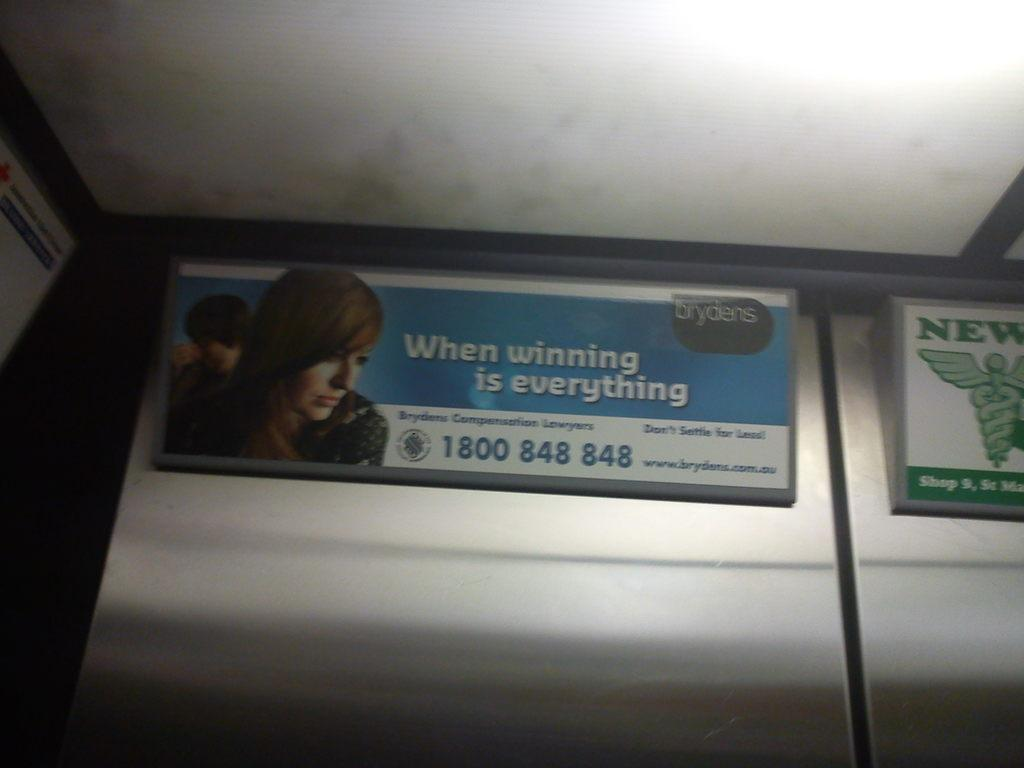What is attached to the wall in the image? There are name boards on the wall in the image. What can be seen on the name boards? People and symbols are present on the name boards. What type of information is visible on the name boards? Text is visible on the name boards. What can be seen in the background of the image? There is a roof visible in the background of the image. How does the watch on the name board sense the time? There is no watch present on the name boards in the image. 